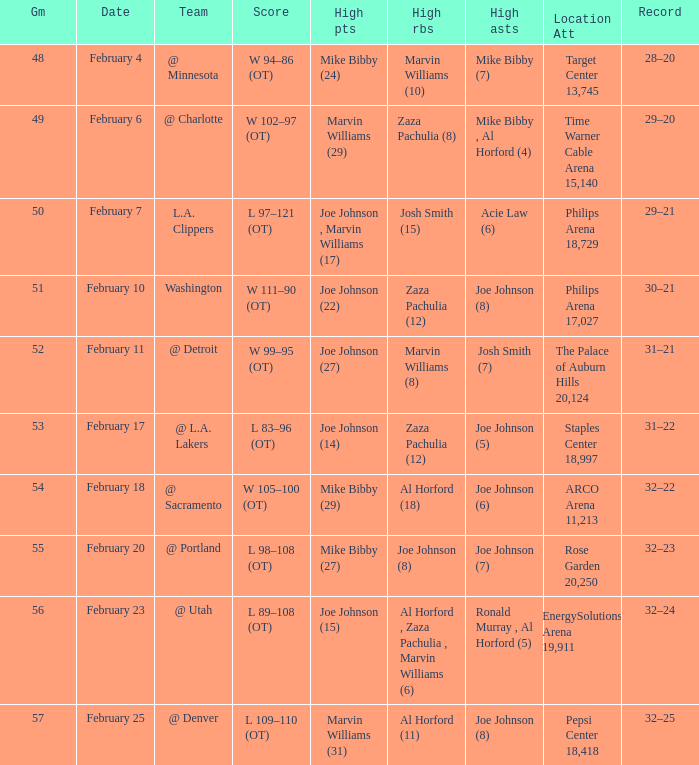Who made high assists on february 4 Mike Bibby (7). 